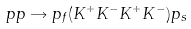<formula> <loc_0><loc_0><loc_500><loc_500>p p \rightarrow p _ { f } ( K ^ { + } K ^ { - } K ^ { + } K ^ { - } ) p _ { s }</formula> 